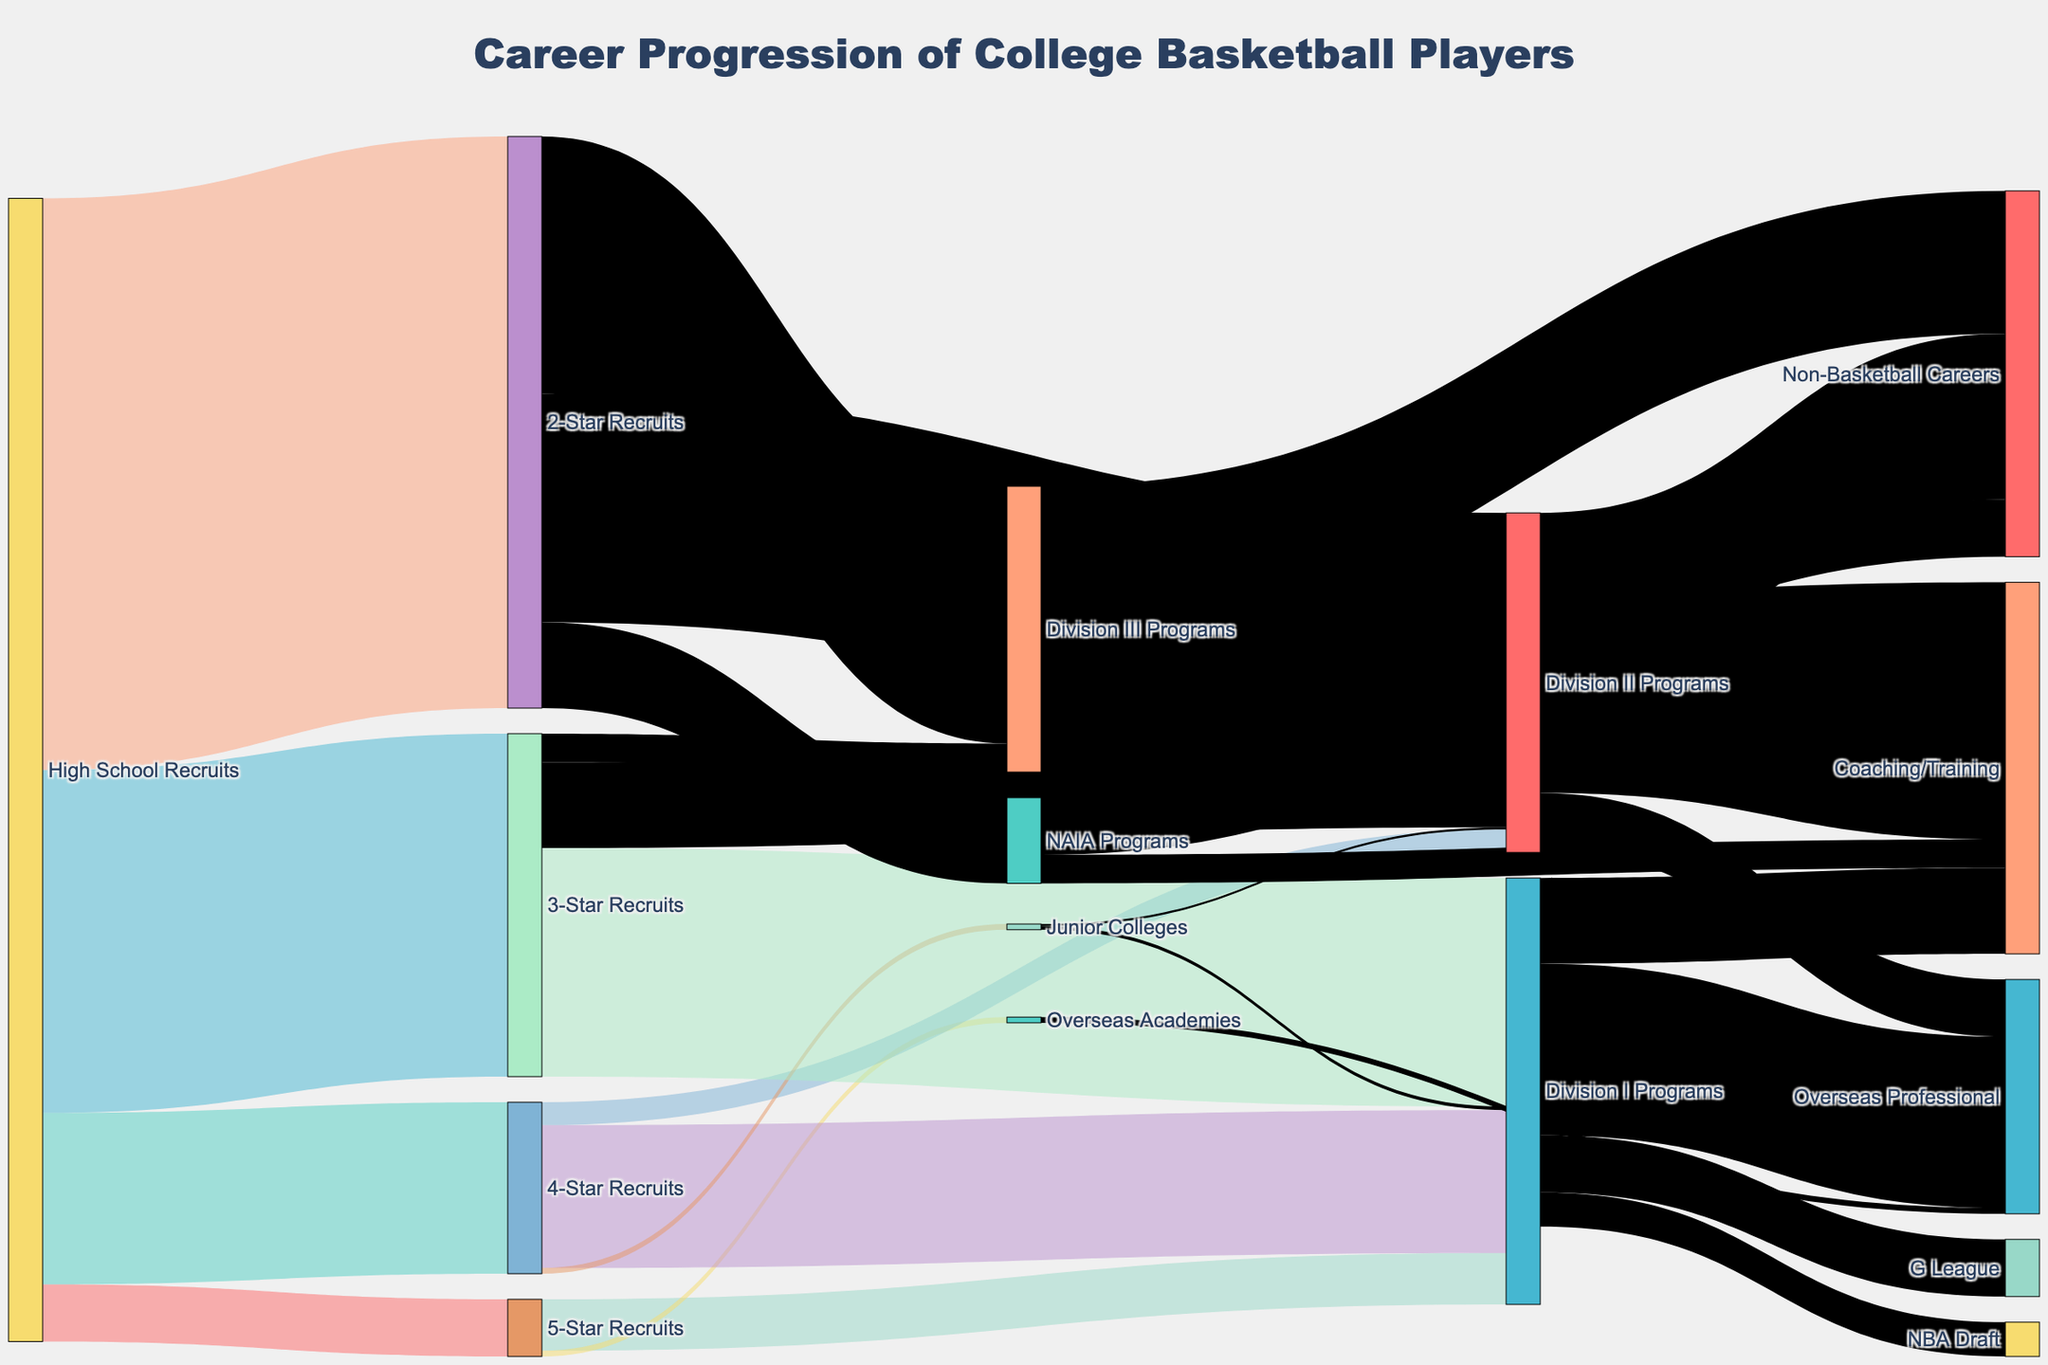what is the title of the figure? The title is typically displayed at the top of the figure. In this case, it reads "Career Progression of College Basketball Players."
Answer: Career Progression of College Basketball Players Which group of recruits has the largest number of players? Examine the values associated with each group of recruits and compare them. The group with the highest value is the one with the largest number of players. The value is largest for the "2-Star Recruits" with 500 players.
Answer: 2-Star Recruits What is the total number of 5-Star Recruits that moved to Division I Programs? Look at the link (the flow) connecting "5-Star Recruits" to "Division I Programs." The number next to this link is 45.
Answer: 45 How many high school recruits become 4-Star or 3-Star Recruits combined? Sum the values of 4-Star Recruits and 3-Star Recruits from high school recruits: 150 (4-Star) + 300 (3-Star) equals 450.
Answer: 450 Which pathway has the smallest number of recruits moving from high school to professional careers? Compare the flows from high school to different professional paths. "Junior Colleges" to "Division II Programs" has the smallest number, which is 2.
Answer: Junior Colleges to Division II Programs What percentage of Division I Program players enter the NBA Draft? Divide the number moving to "NBA Draft" by the total number from "Division I Programs" and multiply by 100. (30 NBA Draft / 195 Division I Programs) * 100 = approx. 15.4%.
Answer: 15.4% How many players from Division II Programs end up in non-basketball careers? Look at the link from "Division II Programs" to "Non-Basketball Careers." The value is 145.
Answer: 145 Which has more players: Division III Programs transitioning to Coaching/Training or NAIA Programs transitioning to Non-Basketball Careers? Compare the values of the two respective flows. Division III Programs to Coaching/Training is 125 and NAIA Programs to Non-Basketball Careers is 50. Therefore, Division III Programs to Coaching/Training has more players.
Answer: Division III Programs to Coaching/Training What career path has the highest number of players from "Overseas Academies"? Look for the flow from "Overseas Academies." Only one path goes to "Overseas Professional," and the number is 5.
Answer: Overseas Professional How many players from Division I Programs pursue careers outside of professional basketball? Add the values for non-professional careers from Division I Programs, which include Coaching/Training: 75.
Answer: 75 